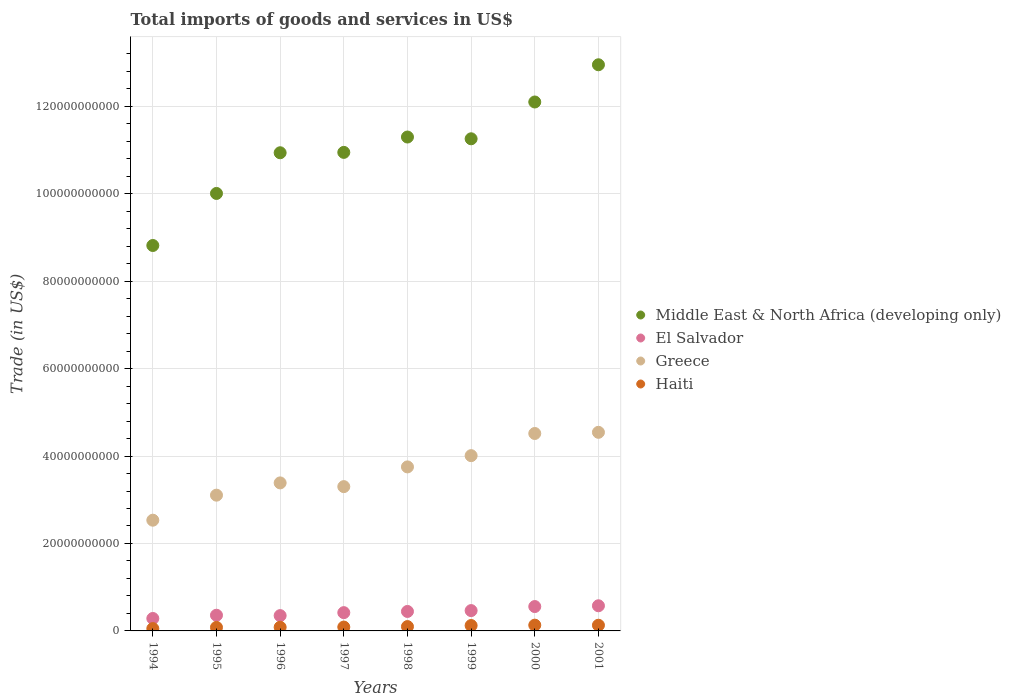How many different coloured dotlines are there?
Ensure brevity in your answer.  4. What is the total imports of goods and services in El Salvador in 1999?
Keep it short and to the point. 4.65e+09. Across all years, what is the maximum total imports of goods and services in Haiti?
Your answer should be very brief. 1.32e+09. Across all years, what is the minimum total imports of goods and services in Haiti?
Offer a terse response. 5.36e+08. In which year was the total imports of goods and services in Greece maximum?
Provide a short and direct response. 2001. In which year was the total imports of goods and services in Middle East & North Africa (developing only) minimum?
Give a very brief answer. 1994. What is the total total imports of goods and services in El Salvador in the graph?
Offer a very short reply. 3.45e+1. What is the difference between the total imports of goods and services in Greece in 1999 and that in 2001?
Your response must be concise. -5.34e+09. What is the difference between the total imports of goods and services in Greece in 1998 and the total imports of goods and services in Haiti in 1994?
Give a very brief answer. 3.70e+1. What is the average total imports of goods and services in Greece per year?
Provide a short and direct response. 3.64e+1. In the year 1995, what is the difference between the total imports of goods and services in Middle East & North Africa (developing only) and total imports of goods and services in Haiti?
Offer a very short reply. 9.92e+1. What is the ratio of the total imports of goods and services in Greece in 1994 to that in 1997?
Your answer should be compact. 0.77. Is the difference between the total imports of goods and services in Middle East & North Africa (developing only) in 1995 and 1998 greater than the difference between the total imports of goods and services in Haiti in 1995 and 1998?
Provide a short and direct response. No. What is the difference between the highest and the second highest total imports of goods and services in Haiti?
Make the answer very short. 2.14e+07. What is the difference between the highest and the lowest total imports of goods and services in Haiti?
Keep it short and to the point. 7.85e+08. In how many years, is the total imports of goods and services in Middle East & North Africa (developing only) greater than the average total imports of goods and services in Middle East & North Africa (developing only) taken over all years?
Provide a succinct answer. 4. Is it the case that in every year, the sum of the total imports of goods and services in El Salvador and total imports of goods and services in Haiti  is greater than the sum of total imports of goods and services in Greece and total imports of goods and services in Middle East & North Africa (developing only)?
Your answer should be compact. Yes. Is the total imports of goods and services in El Salvador strictly greater than the total imports of goods and services in Middle East & North Africa (developing only) over the years?
Your response must be concise. No. Are the values on the major ticks of Y-axis written in scientific E-notation?
Your answer should be compact. No. Does the graph contain any zero values?
Offer a terse response. No. How many legend labels are there?
Provide a short and direct response. 4. How are the legend labels stacked?
Give a very brief answer. Vertical. What is the title of the graph?
Ensure brevity in your answer.  Total imports of goods and services in US$. Does "West Bank and Gaza" appear as one of the legend labels in the graph?
Keep it short and to the point. No. What is the label or title of the Y-axis?
Your answer should be very brief. Trade (in US$). What is the Trade (in US$) in Middle East & North Africa (developing only) in 1994?
Keep it short and to the point. 8.81e+1. What is the Trade (in US$) in El Salvador in 1994?
Provide a succinct answer. 2.85e+09. What is the Trade (in US$) in Greece in 1994?
Provide a short and direct response. 2.53e+1. What is the Trade (in US$) in Haiti in 1994?
Your answer should be very brief. 5.36e+08. What is the Trade (in US$) of Middle East & North Africa (developing only) in 1995?
Your response must be concise. 1.00e+11. What is the Trade (in US$) in El Salvador in 1995?
Make the answer very short. 3.59e+09. What is the Trade (in US$) in Greece in 1995?
Give a very brief answer. 3.10e+1. What is the Trade (in US$) of Haiti in 1995?
Your answer should be compact. 8.08e+08. What is the Trade (in US$) of Middle East & North Africa (developing only) in 1996?
Keep it short and to the point. 1.09e+11. What is the Trade (in US$) of El Salvador in 1996?
Offer a very short reply. 3.50e+09. What is the Trade (in US$) of Greece in 1996?
Give a very brief answer. 3.39e+1. What is the Trade (in US$) of Haiti in 1996?
Offer a very short reply. 8.40e+08. What is the Trade (in US$) of Middle East & North Africa (developing only) in 1997?
Provide a short and direct response. 1.09e+11. What is the Trade (in US$) of El Salvador in 1997?
Offer a very short reply. 4.18e+09. What is the Trade (in US$) in Greece in 1997?
Offer a terse response. 3.30e+1. What is the Trade (in US$) of Haiti in 1997?
Give a very brief answer. 8.83e+08. What is the Trade (in US$) in Middle East & North Africa (developing only) in 1998?
Make the answer very short. 1.13e+11. What is the Trade (in US$) in El Salvador in 1998?
Your answer should be very brief. 4.45e+09. What is the Trade (in US$) in Greece in 1998?
Your answer should be very brief. 3.75e+1. What is the Trade (in US$) in Haiti in 1998?
Provide a short and direct response. 9.91e+08. What is the Trade (in US$) of Middle East & North Africa (developing only) in 1999?
Your response must be concise. 1.13e+11. What is the Trade (in US$) in El Salvador in 1999?
Keep it short and to the point. 4.65e+09. What is the Trade (in US$) of Greece in 1999?
Your answer should be compact. 4.01e+1. What is the Trade (in US$) in Haiti in 1999?
Give a very brief answer. 1.23e+09. What is the Trade (in US$) in Middle East & North Africa (developing only) in 2000?
Provide a succinct answer. 1.21e+11. What is the Trade (in US$) of El Salvador in 2000?
Keep it short and to the point. 5.57e+09. What is the Trade (in US$) in Greece in 2000?
Your answer should be compact. 4.52e+1. What is the Trade (in US$) in Haiti in 2000?
Give a very brief answer. 1.32e+09. What is the Trade (in US$) of Middle East & North Africa (developing only) in 2001?
Keep it short and to the point. 1.29e+11. What is the Trade (in US$) of El Salvador in 2001?
Ensure brevity in your answer.  5.75e+09. What is the Trade (in US$) in Greece in 2001?
Your answer should be compact. 4.54e+1. What is the Trade (in US$) of Haiti in 2001?
Keep it short and to the point. 1.30e+09. Across all years, what is the maximum Trade (in US$) of Middle East & North Africa (developing only)?
Ensure brevity in your answer.  1.29e+11. Across all years, what is the maximum Trade (in US$) in El Salvador?
Your answer should be very brief. 5.75e+09. Across all years, what is the maximum Trade (in US$) of Greece?
Offer a very short reply. 4.54e+1. Across all years, what is the maximum Trade (in US$) of Haiti?
Make the answer very short. 1.32e+09. Across all years, what is the minimum Trade (in US$) in Middle East & North Africa (developing only)?
Provide a short and direct response. 8.81e+1. Across all years, what is the minimum Trade (in US$) of El Salvador?
Provide a succinct answer. 2.85e+09. Across all years, what is the minimum Trade (in US$) in Greece?
Provide a succinct answer. 2.53e+1. Across all years, what is the minimum Trade (in US$) in Haiti?
Ensure brevity in your answer.  5.36e+08. What is the total Trade (in US$) in Middle East & North Africa (developing only) in the graph?
Provide a succinct answer. 8.83e+11. What is the total Trade (in US$) in El Salvador in the graph?
Keep it short and to the point. 3.45e+1. What is the total Trade (in US$) in Greece in the graph?
Offer a very short reply. 2.91e+11. What is the total Trade (in US$) of Haiti in the graph?
Your answer should be very brief. 7.91e+09. What is the difference between the Trade (in US$) in Middle East & North Africa (developing only) in 1994 and that in 1995?
Provide a short and direct response. -1.19e+1. What is the difference between the Trade (in US$) in El Salvador in 1994 and that in 1995?
Offer a very short reply. -7.40e+08. What is the difference between the Trade (in US$) in Greece in 1994 and that in 1995?
Your answer should be compact. -5.72e+09. What is the difference between the Trade (in US$) of Haiti in 1994 and that in 1995?
Your answer should be compact. -2.72e+08. What is the difference between the Trade (in US$) in Middle East & North Africa (developing only) in 1994 and that in 1996?
Make the answer very short. -2.12e+1. What is the difference between the Trade (in US$) of El Salvador in 1994 and that in 1996?
Your answer should be very brief. -6.54e+08. What is the difference between the Trade (in US$) of Greece in 1994 and that in 1996?
Your response must be concise. -8.53e+09. What is the difference between the Trade (in US$) in Haiti in 1994 and that in 1996?
Provide a short and direct response. -3.04e+08. What is the difference between the Trade (in US$) in Middle East & North Africa (developing only) in 1994 and that in 1997?
Provide a succinct answer. -2.13e+1. What is the difference between the Trade (in US$) of El Salvador in 1994 and that in 1997?
Ensure brevity in your answer.  -1.33e+09. What is the difference between the Trade (in US$) in Greece in 1994 and that in 1997?
Offer a very short reply. -7.68e+09. What is the difference between the Trade (in US$) of Haiti in 1994 and that in 1997?
Your answer should be compact. -3.47e+08. What is the difference between the Trade (in US$) of Middle East & North Africa (developing only) in 1994 and that in 1998?
Ensure brevity in your answer.  -2.48e+1. What is the difference between the Trade (in US$) in El Salvador in 1994 and that in 1998?
Provide a short and direct response. -1.61e+09. What is the difference between the Trade (in US$) of Greece in 1994 and that in 1998?
Offer a very short reply. -1.22e+1. What is the difference between the Trade (in US$) of Haiti in 1994 and that in 1998?
Offer a terse response. -4.56e+08. What is the difference between the Trade (in US$) of Middle East & North Africa (developing only) in 1994 and that in 1999?
Your answer should be very brief. -2.44e+1. What is the difference between the Trade (in US$) of El Salvador in 1994 and that in 1999?
Your response must be concise. -1.80e+09. What is the difference between the Trade (in US$) of Greece in 1994 and that in 1999?
Your response must be concise. -1.48e+1. What is the difference between the Trade (in US$) in Haiti in 1994 and that in 1999?
Provide a short and direct response. -6.98e+08. What is the difference between the Trade (in US$) of Middle East & North Africa (developing only) in 1994 and that in 2000?
Provide a short and direct response. -3.28e+1. What is the difference between the Trade (in US$) in El Salvador in 1994 and that in 2000?
Provide a succinct answer. -2.73e+09. What is the difference between the Trade (in US$) in Greece in 1994 and that in 2000?
Provide a succinct answer. -1.98e+1. What is the difference between the Trade (in US$) of Haiti in 1994 and that in 2000?
Give a very brief answer. -7.85e+08. What is the difference between the Trade (in US$) of Middle East & North Africa (developing only) in 1994 and that in 2001?
Give a very brief answer. -4.13e+1. What is the difference between the Trade (in US$) of El Salvador in 1994 and that in 2001?
Your response must be concise. -2.90e+09. What is the difference between the Trade (in US$) of Greece in 1994 and that in 2001?
Give a very brief answer. -2.01e+1. What is the difference between the Trade (in US$) in Haiti in 1994 and that in 2001?
Ensure brevity in your answer.  -7.64e+08. What is the difference between the Trade (in US$) in Middle East & North Africa (developing only) in 1995 and that in 1996?
Offer a terse response. -9.30e+09. What is the difference between the Trade (in US$) in El Salvador in 1995 and that in 1996?
Your answer should be very brief. 8.70e+07. What is the difference between the Trade (in US$) in Greece in 1995 and that in 1996?
Provide a succinct answer. -2.81e+09. What is the difference between the Trade (in US$) of Haiti in 1995 and that in 1996?
Your response must be concise. -3.23e+07. What is the difference between the Trade (in US$) in Middle East & North Africa (developing only) in 1995 and that in 1997?
Provide a short and direct response. -9.39e+09. What is the difference between the Trade (in US$) in El Salvador in 1995 and that in 1997?
Make the answer very short. -5.94e+08. What is the difference between the Trade (in US$) in Greece in 1995 and that in 1997?
Your response must be concise. -1.95e+09. What is the difference between the Trade (in US$) of Haiti in 1995 and that in 1997?
Give a very brief answer. -7.50e+07. What is the difference between the Trade (in US$) in Middle East & North Africa (developing only) in 1995 and that in 1998?
Give a very brief answer. -1.29e+1. What is the difference between the Trade (in US$) in El Salvador in 1995 and that in 1998?
Give a very brief answer. -8.66e+08. What is the difference between the Trade (in US$) in Greece in 1995 and that in 1998?
Your answer should be very brief. -6.46e+09. What is the difference between the Trade (in US$) of Haiti in 1995 and that in 1998?
Give a very brief answer. -1.83e+08. What is the difference between the Trade (in US$) of Middle East & North Africa (developing only) in 1995 and that in 1999?
Your answer should be compact. -1.25e+1. What is the difference between the Trade (in US$) in El Salvador in 1995 and that in 1999?
Make the answer very short. -1.06e+09. What is the difference between the Trade (in US$) in Greece in 1995 and that in 1999?
Provide a succinct answer. -9.04e+09. What is the difference between the Trade (in US$) in Haiti in 1995 and that in 1999?
Offer a terse response. -4.26e+08. What is the difference between the Trade (in US$) of Middle East & North Africa (developing only) in 1995 and that in 2000?
Give a very brief answer. -2.09e+1. What is the difference between the Trade (in US$) in El Salvador in 1995 and that in 2000?
Your response must be concise. -1.99e+09. What is the difference between the Trade (in US$) in Greece in 1995 and that in 2000?
Provide a succinct answer. -1.41e+1. What is the difference between the Trade (in US$) in Haiti in 1995 and that in 2000?
Keep it short and to the point. -5.13e+08. What is the difference between the Trade (in US$) of Middle East & North Africa (developing only) in 1995 and that in 2001?
Give a very brief answer. -2.94e+1. What is the difference between the Trade (in US$) of El Salvador in 1995 and that in 2001?
Your response must be concise. -2.16e+09. What is the difference between the Trade (in US$) of Greece in 1995 and that in 2001?
Ensure brevity in your answer.  -1.44e+1. What is the difference between the Trade (in US$) in Haiti in 1995 and that in 2001?
Your response must be concise. -4.92e+08. What is the difference between the Trade (in US$) in Middle East & North Africa (developing only) in 1996 and that in 1997?
Give a very brief answer. -8.62e+07. What is the difference between the Trade (in US$) of El Salvador in 1996 and that in 1997?
Offer a terse response. -6.81e+08. What is the difference between the Trade (in US$) of Greece in 1996 and that in 1997?
Make the answer very short. 8.53e+08. What is the difference between the Trade (in US$) in Haiti in 1996 and that in 1997?
Keep it short and to the point. -4.27e+07. What is the difference between the Trade (in US$) in Middle East & North Africa (developing only) in 1996 and that in 1998?
Keep it short and to the point. -3.60e+09. What is the difference between the Trade (in US$) in El Salvador in 1996 and that in 1998?
Offer a terse response. -9.53e+08. What is the difference between the Trade (in US$) of Greece in 1996 and that in 1998?
Offer a terse response. -3.66e+09. What is the difference between the Trade (in US$) of Haiti in 1996 and that in 1998?
Keep it short and to the point. -1.51e+08. What is the difference between the Trade (in US$) of Middle East & North Africa (developing only) in 1996 and that in 1999?
Offer a very short reply. -3.19e+09. What is the difference between the Trade (in US$) in El Salvador in 1996 and that in 1999?
Offer a very short reply. -1.15e+09. What is the difference between the Trade (in US$) of Greece in 1996 and that in 1999?
Your answer should be very brief. -6.23e+09. What is the difference between the Trade (in US$) in Haiti in 1996 and that in 1999?
Your response must be concise. -3.93e+08. What is the difference between the Trade (in US$) of Middle East & North Africa (developing only) in 1996 and that in 2000?
Give a very brief answer. -1.16e+1. What is the difference between the Trade (in US$) in El Salvador in 1996 and that in 2000?
Offer a terse response. -2.07e+09. What is the difference between the Trade (in US$) of Greece in 1996 and that in 2000?
Keep it short and to the point. -1.13e+1. What is the difference between the Trade (in US$) of Haiti in 1996 and that in 2000?
Your answer should be very brief. -4.81e+08. What is the difference between the Trade (in US$) in Middle East & North Africa (developing only) in 1996 and that in 2001?
Your response must be concise. -2.01e+1. What is the difference between the Trade (in US$) of El Salvador in 1996 and that in 2001?
Your response must be concise. -2.25e+09. What is the difference between the Trade (in US$) in Greece in 1996 and that in 2001?
Ensure brevity in your answer.  -1.16e+1. What is the difference between the Trade (in US$) of Haiti in 1996 and that in 2001?
Provide a succinct answer. -4.60e+08. What is the difference between the Trade (in US$) of Middle East & North Africa (developing only) in 1997 and that in 1998?
Offer a terse response. -3.51e+09. What is the difference between the Trade (in US$) of El Salvador in 1997 and that in 1998?
Your response must be concise. -2.72e+08. What is the difference between the Trade (in US$) of Greece in 1997 and that in 1998?
Ensure brevity in your answer.  -4.51e+09. What is the difference between the Trade (in US$) in Haiti in 1997 and that in 1998?
Provide a succinct answer. -1.08e+08. What is the difference between the Trade (in US$) in Middle East & North Africa (developing only) in 1997 and that in 1999?
Your answer should be very brief. -3.11e+09. What is the difference between the Trade (in US$) in El Salvador in 1997 and that in 1999?
Your answer should be very brief. -4.66e+08. What is the difference between the Trade (in US$) in Greece in 1997 and that in 1999?
Offer a terse response. -7.08e+09. What is the difference between the Trade (in US$) of Haiti in 1997 and that in 1999?
Ensure brevity in your answer.  -3.51e+08. What is the difference between the Trade (in US$) of Middle East & North Africa (developing only) in 1997 and that in 2000?
Give a very brief answer. -1.15e+1. What is the difference between the Trade (in US$) in El Salvador in 1997 and that in 2000?
Provide a short and direct response. -1.39e+09. What is the difference between the Trade (in US$) of Greece in 1997 and that in 2000?
Offer a very short reply. -1.22e+1. What is the difference between the Trade (in US$) in Haiti in 1997 and that in 2000?
Your response must be concise. -4.38e+08. What is the difference between the Trade (in US$) in Middle East & North Africa (developing only) in 1997 and that in 2001?
Keep it short and to the point. -2.00e+1. What is the difference between the Trade (in US$) in El Salvador in 1997 and that in 2001?
Ensure brevity in your answer.  -1.57e+09. What is the difference between the Trade (in US$) of Greece in 1997 and that in 2001?
Your response must be concise. -1.24e+1. What is the difference between the Trade (in US$) in Haiti in 1997 and that in 2001?
Ensure brevity in your answer.  -4.17e+08. What is the difference between the Trade (in US$) in Middle East & North Africa (developing only) in 1998 and that in 1999?
Your answer should be very brief. 4.03e+08. What is the difference between the Trade (in US$) of El Salvador in 1998 and that in 1999?
Offer a very short reply. -1.94e+08. What is the difference between the Trade (in US$) in Greece in 1998 and that in 1999?
Ensure brevity in your answer.  -2.57e+09. What is the difference between the Trade (in US$) of Haiti in 1998 and that in 1999?
Make the answer very short. -2.42e+08. What is the difference between the Trade (in US$) of Middle East & North Africa (developing only) in 1998 and that in 2000?
Provide a short and direct response. -8.01e+09. What is the difference between the Trade (in US$) in El Salvador in 1998 and that in 2000?
Your response must be concise. -1.12e+09. What is the difference between the Trade (in US$) of Greece in 1998 and that in 2000?
Your answer should be very brief. -7.64e+09. What is the difference between the Trade (in US$) in Haiti in 1998 and that in 2000?
Your answer should be compact. -3.30e+08. What is the difference between the Trade (in US$) of Middle East & North Africa (developing only) in 1998 and that in 2001?
Your answer should be compact. -1.65e+1. What is the difference between the Trade (in US$) in El Salvador in 1998 and that in 2001?
Provide a short and direct response. -1.30e+09. What is the difference between the Trade (in US$) of Greece in 1998 and that in 2001?
Give a very brief answer. -7.91e+09. What is the difference between the Trade (in US$) in Haiti in 1998 and that in 2001?
Give a very brief answer. -3.08e+08. What is the difference between the Trade (in US$) of Middle East & North Africa (developing only) in 1999 and that in 2000?
Give a very brief answer. -8.42e+09. What is the difference between the Trade (in US$) in El Salvador in 1999 and that in 2000?
Offer a terse response. -9.26e+08. What is the difference between the Trade (in US$) in Greece in 1999 and that in 2000?
Give a very brief answer. -5.07e+09. What is the difference between the Trade (in US$) in Haiti in 1999 and that in 2000?
Offer a very short reply. -8.75e+07. What is the difference between the Trade (in US$) in Middle East & North Africa (developing only) in 1999 and that in 2001?
Your answer should be very brief. -1.69e+1. What is the difference between the Trade (in US$) of El Salvador in 1999 and that in 2001?
Your response must be concise. -1.10e+09. What is the difference between the Trade (in US$) of Greece in 1999 and that in 2001?
Provide a succinct answer. -5.34e+09. What is the difference between the Trade (in US$) of Haiti in 1999 and that in 2001?
Offer a very short reply. -6.62e+07. What is the difference between the Trade (in US$) of Middle East & North Africa (developing only) in 2000 and that in 2001?
Ensure brevity in your answer.  -8.51e+09. What is the difference between the Trade (in US$) of El Salvador in 2000 and that in 2001?
Your answer should be very brief. -1.78e+08. What is the difference between the Trade (in US$) of Greece in 2000 and that in 2001?
Offer a terse response. -2.69e+08. What is the difference between the Trade (in US$) of Haiti in 2000 and that in 2001?
Provide a short and direct response. 2.14e+07. What is the difference between the Trade (in US$) in Middle East & North Africa (developing only) in 1994 and the Trade (in US$) in El Salvador in 1995?
Your answer should be compact. 8.46e+1. What is the difference between the Trade (in US$) of Middle East & North Africa (developing only) in 1994 and the Trade (in US$) of Greece in 1995?
Provide a short and direct response. 5.71e+1. What is the difference between the Trade (in US$) of Middle East & North Africa (developing only) in 1994 and the Trade (in US$) of Haiti in 1995?
Your answer should be very brief. 8.73e+1. What is the difference between the Trade (in US$) in El Salvador in 1994 and the Trade (in US$) in Greece in 1995?
Keep it short and to the point. -2.82e+1. What is the difference between the Trade (in US$) in El Salvador in 1994 and the Trade (in US$) in Haiti in 1995?
Keep it short and to the point. 2.04e+09. What is the difference between the Trade (in US$) in Greece in 1994 and the Trade (in US$) in Haiti in 1995?
Offer a very short reply. 2.45e+1. What is the difference between the Trade (in US$) of Middle East & North Africa (developing only) in 1994 and the Trade (in US$) of El Salvador in 1996?
Provide a short and direct response. 8.46e+1. What is the difference between the Trade (in US$) of Middle East & North Africa (developing only) in 1994 and the Trade (in US$) of Greece in 1996?
Your answer should be very brief. 5.43e+1. What is the difference between the Trade (in US$) of Middle East & North Africa (developing only) in 1994 and the Trade (in US$) of Haiti in 1996?
Your response must be concise. 8.73e+1. What is the difference between the Trade (in US$) of El Salvador in 1994 and the Trade (in US$) of Greece in 1996?
Offer a very short reply. -3.10e+1. What is the difference between the Trade (in US$) in El Salvador in 1994 and the Trade (in US$) in Haiti in 1996?
Offer a very short reply. 2.01e+09. What is the difference between the Trade (in US$) of Greece in 1994 and the Trade (in US$) of Haiti in 1996?
Your response must be concise. 2.45e+1. What is the difference between the Trade (in US$) in Middle East & North Africa (developing only) in 1994 and the Trade (in US$) in El Salvador in 1997?
Keep it short and to the point. 8.40e+1. What is the difference between the Trade (in US$) of Middle East & North Africa (developing only) in 1994 and the Trade (in US$) of Greece in 1997?
Your answer should be compact. 5.51e+1. What is the difference between the Trade (in US$) of Middle East & North Africa (developing only) in 1994 and the Trade (in US$) of Haiti in 1997?
Ensure brevity in your answer.  8.73e+1. What is the difference between the Trade (in US$) of El Salvador in 1994 and the Trade (in US$) of Greece in 1997?
Offer a terse response. -3.02e+1. What is the difference between the Trade (in US$) in El Salvador in 1994 and the Trade (in US$) in Haiti in 1997?
Keep it short and to the point. 1.96e+09. What is the difference between the Trade (in US$) in Greece in 1994 and the Trade (in US$) in Haiti in 1997?
Make the answer very short. 2.44e+1. What is the difference between the Trade (in US$) in Middle East & North Africa (developing only) in 1994 and the Trade (in US$) in El Salvador in 1998?
Offer a terse response. 8.37e+1. What is the difference between the Trade (in US$) in Middle East & North Africa (developing only) in 1994 and the Trade (in US$) in Greece in 1998?
Ensure brevity in your answer.  5.06e+1. What is the difference between the Trade (in US$) in Middle East & North Africa (developing only) in 1994 and the Trade (in US$) in Haiti in 1998?
Provide a succinct answer. 8.72e+1. What is the difference between the Trade (in US$) of El Salvador in 1994 and the Trade (in US$) of Greece in 1998?
Offer a terse response. -3.47e+1. What is the difference between the Trade (in US$) of El Salvador in 1994 and the Trade (in US$) of Haiti in 1998?
Your response must be concise. 1.86e+09. What is the difference between the Trade (in US$) in Greece in 1994 and the Trade (in US$) in Haiti in 1998?
Your response must be concise. 2.43e+1. What is the difference between the Trade (in US$) of Middle East & North Africa (developing only) in 1994 and the Trade (in US$) of El Salvador in 1999?
Offer a terse response. 8.35e+1. What is the difference between the Trade (in US$) in Middle East & North Africa (developing only) in 1994 and the Trade (in US$) in Greece in 1999?
Offer a terse response. 4.81e+1. What is the difference between the Trade (in US$) in Middle East & North Africa (developing only) in 1994 and the Trade (in US$) in Haiti in 1999?
Give a very brief answer. 8.69e+1. What is the difference between the Trade (in US$) of El Salvador in 1994 and the Trade (in US$) of Greece in 1999?
Keep it short and to the point. -3.72e+1. What is the difference between the Trade (in US$) in El Salvador in 1994 and the Trade (in US$) in Haiti in 1999?
Your response must be concise. 1.61e+09. What is the difference between the Trade (in US$) of Greece in 1994 and the Trade (in US$) of Haiti in 1999?
Give a very brief answer. 2.41e+1. What is the difference between the Trade (in US$) of Middle East & North Africa (developing only) in 1994 and the Trade (in US$) of El Salvador in 2000?
Make the answer very short. 8.26e+1. What is the difference between the Trade (in US$) in Middle East & North Africa (developing only) in 1994 and the Trade (in US$) in Greece in 2000?
Offer a terse response. 4.30e+1. What is the difference between the Trade (in US$) of Middle East & North Africa (developing only) in 1994 and the Trade (in US$) of Haiti in 2000?
Keep it short and to the point. 8.68e+1. What is the difference between the Trade (in US$) of El Salvador in 1994 and the Trade (in US$) of Greece in 2000?
Provide a short and direct response. -4.23e+1. What is the difference between the Trade (in US$) in El Salvador in 1994 and the Trade (in US$) in Haiti in 2000?
Your response must be concise. 1.53e+09. What is the difference between the Trade (in US$) of Greece in 1994 and the Trade (in US$) of Haiti in 2000?
Provide a succinct answer. 2.40e+1. What is the difference between the Trade (in US$) in Middle East & North Africa (developing only) in 1994 and the Trade (in US$) in El Salvador in 2001?
Ensure brevity in your answer.  8.24e+1. What is the difference between the Trade (in US$) in Middle East & North Africa (developing only) in 1994 and the Trade (in US$) in Greece in 2001?
Provide a short and direct response. 4.27e+1. What is the difference between the Trade (in US$) in Middle East & North Africa (developing only) in 1994 and the Trade (in US$) in Haiti in 2001?
Your answer should be compact. 8.68e+1. What is the difference between the Trade (in US$) in El Salvador in 1994 and the Trade (in US$) in Greece in 2001?
Keep it short and to the point. -4.26e+1. What is the difference between the Trade (in US$) in El Salvador in 1994 and the Trade (in US$) in Haiti in 2001?
Your answer should be very brief. 1.55e+09. What is the difference between the Trade (in US$) in Greece in 1994 and the Trade (in US$) in Haiti in 2001?
Your response must be concise. 2.40e+1. What is the difference between the Trade (in US$) in Middle East & North Africa (developing only) in 1995 and the Trade (in US$) in El Salvador in 1996?
Provide a short and direct response. 9.66e+1. What is the difference between the Trade (in US$) of Middle East & North Africa (developing only) in 1995 and the Trade (in US$) of Greece in 1996?
Make the answer very short. 6.62e+1. What is the difference between the Trade (in US$) in Middle East & North Africa (developing only) in 1995 and the Trade (in US$) in Haiti in 1996?
Your answer should be very brief. 9.92e+1. What is the difference between the Trade (in US$) in El Salvador in 1995 and the Trade (in US$) in Greece in 1996?
Offer a terse response. -3.03e+1. What is the difference between the Trade (in US$) in El Salvador in 1995 and the Trade (in US$) in Haiti in 1996?
Your answer should be compact. 2.75e+09. What is the difference between the Trade (in US$) of Greece in 1995 and the Trade (in US$) of Haiti in 1996?
Provide a succinct answer. 3.02e+1. What is the difference between the Trade (in US$) of Middle East & North Africa (developing only) in 1995 and the Trade (in US$) of El Salvador in 1997?
Your answer should be compact. 9.59e+1. What is the difference between the Trade (in US$) in Middle East & North Africa (developing only) in 1995 and the Trade (in US$) in Greece in 1997?
Make the answer very short. 6.71e+1. What is the difference between the Trade (in US$) in Middle East & North Africa (developing only) in 1995 and the Trade (in US$) in Haiti in 1997?
Provide a short and direct response. 9.92e+1. What is the difference between the Trade (in US$) in El Salvador in 1995 and the Trade (in US$) in Greece in 1997?
Provide a succinct answer. -2.94e+1. What is the difference between the Trade (in US$) of El Salvador in 1995 and the Trade (in US$) of Haiti in 1997?
Offer a very short reply. 2.70e+09. What is the difference between the Trade (in US$) of Greece in 1995 and the Trade (in US$) of Haiti in 1997?
Provide a succinct answer. 3.02e+1. What is the difference between the Trade (in US$) in Middle East & North Africa (developing only) in 1995 and the Trade (in US$) in El Salvador in 1998?
Offer a terse response. 9.56e+1. What is the difference between the Trade (in US$) in Middle East & North Africa (developing only) in 1995 and the Trade (in US$) in Greece in 1998?
Your answer should be compact. 6.25e+1. What is the difference between the Trade (in US$) in Middle East & North Africa (developing only) in 1995 and the Trade (in US$) in Haiti in 1998?
Provide a succinct answer. 9.91e+1. What is the difference between the Trade (in US$) of El Salvador in 1995 and the Trade (in US$) of Greece in 1998?
Keep it short and to the point. -3.39e+1. What is the difference between the Trade (in US$) in El Salvador in 1995 and the Trade (in US$) in Haiti in 1998?
Offer a terse response. 2.60e+09. What is the difference between the Trade (in US$) of Greece in 1995 and the Trade (in US$) of Haiti in 1998?
Offer a very short reply. 3.01e+1. What is the difference between the Trade (in US$) of Middle East & North Africa (developing only) in 1995 and the Trade (in US$) of El Salvador in 1999?
Make the answer very short. 9.54e+1. What is the difference between the Trade (in US$) in Middle East & North Africa (developing only) in 1995 and the Trade (in US$) in Greece in 1999?
Give a very brief answer. 6.00e+1. What is the difference between the Trade (in US$) of Middle East & North Africa (developing only) in 1995 and the Trade (in US$) of Haiti in 1999?
Your answer should be very brief. 9.88e+1. What is the difference between the Trade (in US$) in El Salvador in 1995 and the Trade (in US$) in Greece in 1999?
Give a very brief answer. -3.65e+1. What is the difference between the Trade (in US$) in El Salvador in 1995 and the Trade (in US$) in Haiti in 1999?
Provide a succinct answer. 2.35e+09. What is the difference between the Trade (in US$) of Greece in 1995 and the Trade (in US$) of Haiti in 1999?
Offer a very short reply. 2.98e+1. What is the difference between the Trade (in US$) in Middle East & North Africa (developing only) in 1995 and the Trade (in US$) in El Salvador in 2000?
Provide a succinct answer. 9.45e+1. What is the difference between the Trade (in US$) of Middle East & North Africa (developing only) in 1995 and the Trade (in US$) of Greece in 2000?
Your answer should be compact. 5.49e+1. What is the difference between the Trade (in US$) in Middle East & North Africa (developing only) in 1995 and the Trade (in US$) in Haiti in 2000?
Provide a short and direct response. 9.87e+1. What is the difference between the Trade (in US$) of El Salvador in 1995 and the Trade (in US$) of Greece in 2000?
Provide a short and direct response. -4.16e+1. What is the difference between the Trade (in US$) in El Salvador in 1995 and the Trade (in US$) in Haiti in 2000?
Make the answer very short. 2.27e+09. What is the difference between the Trade (in US$) in Greece in 1995 and the Trade (in US$) in Haiti in 2000?
Keep it short and to the point. 2.97e+1. What is the difference between the Trade (in US$) of Middle East & North Africa (developing only) in 1995 and the Trade (in US$) of El Salvador in 2001?
Your answer should be very brief. 9.43e+1. What is the difference between the Trade (in US$) of Middle East & North Africa (developing only) in 1995 and the Trade (in US$) of Greece in 2001?
Give a very brief answer. 5.46e+1. What is the difference between the Trade (in US$) in Middle East & North Africa (developing only) in 1995 and the Trade (in US$) in Haiti in 2001?
Your answer should be compact. 9.88e+1. What is the difference between the Trade (in US$) in El Salvador in 1995 and the Trade (in US$) in Greece in 2001?
Your answer should be very brief. -4.18e+1. What is the difference between the Trade (in US$) in El Salvador in 1995 and the Trade (in US$) in Haiti in 2001?
Offer a terse response. 2.29e+09. What is the difference between the Trade (in US$) in Greece in 1995 and the Trade (in US$) in Haiti in 2001?
Your answer should be compact. 2.97e+1. What is the difference between the Trade (in US$) in Middle East & North Africa (developing only) in 1996 and the Trade (in US$) in El Salvador in 1997?
Your response must be concise. 1.05e+11. What is the difference between the Trade (in US$) of Middle East & North Africa (developing only) in 1996 and the Trade (in US$) of Greece in 1997?
Your answer should be very brief. 7.64e+1. What is the difference between the Trade (in US$) in Middle East & North Africa (developing only) in 1996 and the Trade (in US$) in Haiti in 1997?
Make the answer very short. 1.08e+11. What is the difference between the Trade (in US$) of El Salvador in 1996 and the Trade (in US$) of Greece in 1997?
Make the answer very short. -2.95e+1. What is the difference between the Trade (in US$) of El Salvador in 1996 and the Trade (in US$) of Haiti in 1997?
Offer a very short reply. 2.62e+09. What is the difference between the Trade (in US$) in Greece in 1996 and the Trade (in US$) in Haiti in 1997?
Your answer should be compact. 3.30e+1. What is the difference between the Trade (in US$) in Middle East & North Africa (developing only) in 1996 and the Trade (in US$) in El Salvador in 1998?
Your answer should be very brief. 1.05e+11. What is the difference between the Trade (in US$) in Middle East & North Africa (developing only) in 1996 and the Trade (in US$) in Greece in 1998?
Your answer should be compact. 7.18e+1. What is the difference between the Trade (in US$) of Middle East & North Africa (developing only) in 1996 and the Trade (in US$) of Haiti in 1998?
Your response must be concise. 1.08e+11. What is the difference between the Trade (in US$) of El Salvador in 1996 and the Trade (in US$) of Greece in 1998?
Offer a very short reply. -3.40e+1. What is the difference between the Trade (in US$) of El Salvador in 1996 and the Trade (in US$) of Haiti in 1998?
Offer a terse response. 2.51e+09. What is the difference between the Trade (in US$) of Greece in 1996 and the Trade (in US$) of Haiti in 1998?
Offer a terse response. 3.29e+1. What is the difference between the Trade (in US$) of Middle East & North Africa (developing only) in 1996 and the Trade (in US$) of El Salvador in 1999?
Give a very brief answer. 1.05e+11. What is the difference between the Trade (in US$) in Middle East & North Africa (developing only) in 1996 and the Trade (in US$) in Greece in 1999?
Your answer should be compact. 6.93e+1. What is the difference between the Trade (in US$) of Middle East & North Africa (developing only) in 1996 and the Trade (in US$) of Haiti in 1999?
Provide a succinct answer. 1.08e+11. What is the difference between the Trade (in US$) of El Salvador in 1996 and the Trade (in US$) of Greece in 1999?
Keep it short and to the point. -3.66e+1. What is the difference between the Trade (in US$) in El Salvador in 1996 and the Trade (in US$) in Haiti in 1999?
Offer a terse response. 2.27e+09. What is the difference between the Trade (in US$) in Greece in 1996 and the Trade (in US$) in Haiti in 1999?
Give a very brief answer. 3.26e+1. What is the difference between the Trade (in US$) of Middle East & North Africa (developing only) in 1996 and the Trade (in US$) of El Salvador in 2000?
Offer a very short reply. 1.04e+11. What is the difference between the Trade (in US$) of Middle East & North Africa (developing only) in 1996 and the Trade (in US$) of Greece in 2000?
Your answer should be very brief. 6.42e+1. What is the difference between the Trade (in US$) of Middle East & North Africa (developing only) in 1996 and the Trade (in US$) of Haiti in 2000?
Keep it short and to the point. 1.08e+11. What is the difference between the Trade (in US$) in El Salvador in 1996 and the Trade (in US$) in Greece in 2000?
Provide a short and direct response. -4.17e+1. What is the difference between the Trade (in US$) of El Salvador in 1996 and the Trade (in US$) of Haiti in 2000?
Offer a terse response. 2.18e+09. What is the difference between the Trade (in US$) of Greece in 1996 and the Trade (in US$) of Haiti in 2000?
Your answer should be compact. 3.25e+1. What is the difference between the Trade (in US$) of Middle East & North Africa (developing only) in 1996 and the Trade (in US$) of El Salvador in 2001?
Make the answer very short. 1.04e+11. What is the difference between the Trade (in US$) of Middle East & North Africa (developing only) in 1996 and the Trade (in US$) of Greece in 2001?
Keep it short and to the point. 6.39e+1. What is the difference between the Trade (in US$) of Middle East & North Africa (developing only) in 1996 and the Trade (in US$) of Haiti in 2001?
Offer a very short reply. 1.08e+11. What is the difference between the Trade (in US$) of El Salvador in 1996 and the Trade (in US$) of Greece in 2001?
Ensure brevity in your answer.  -4.19e+1. What is the difference between the Trade (in US$) in El Salvador in 1996 and the Trade (in US$) in Haiti in 2001?
Provide a short and direct response. 2.20e+09. What is the difference between the Trade (in US$) of Greece in 1996 and the Trade (in US$) of Haiti in 2001?
Offer a very short reply. 3.26e+1. What is the difference between the Trade (in US$) in Middle East & North Africa (developing only) in 1997 and the Trade (in US$) in El Salvador in 1998?
Ensure brevity in your answer.  1.05e+11. What is the difference between the Trade (in US$) of Middle East & North Africa (developing only) in 1997 and the Trade (in US$) of Greece in 1998?
Provide a short and direct response. 7.19e+1. What is the difference between the Trade (in US$) of Middle East & North Africa (developing only) in 1997 and the Trade (in US$) of Haiti in 1998?
Keep it short and to the point. 1.08e+11. What is the difference between the Trade (in US$) in El Salvador in 1997 and the Trade (in US$) in Greece in 1998?
Offer a very short reply. -3.33e+1. What is the difference between the Trade (in US$) of El Salvador in 1997 and the Trade (in US$) of Haiti in 1998?
Offer a terse response. 3.19e+09. What is the difference between the Trade (in US$) of Greece in 1997 and the Trade (in US$) of Haiti in 1998?
Your response must be concise. 3.20e+1. What is the difference between the Trade (in US$) of Middle East & North Africa (developing only) in 1997 and the Trade (in US$) of El Salvador in 1999?
Give a very brief answer. 1.05e+11. What is the difference between the Trade (in US$) of Middle East & North Africa (developing only) in 1997 and the Trade (in US$) of Greece in 1999?
Give a very brief answer. 6.94e+1. What is the difference between the Trade (in US$) in Middle East & North Africa (developing only) in 1997 and the Trade (in US$) in Haiti in 1999?
Your answer should be very brief. 1.08e+11. What is the difference between the Trade (in US$) in El Salvador in 1997 and the Trade (in US$) in Greece in 1999?
Offer a very short reply. -3.59e+1. What is the difference between the Trade (in US$) of El Salvador in 1997 and the Trade (in US$) of Haiti in 1999?
Offer a terse response. 2.95e+09. What is the difference between the Trade (in US$) of Greece in 1997 and the Trade (in US$) of Haiti in 1999?
Offer a very short reply. 3.18e+1. What is the difference between the Trade (in US$) of Middle East & North Africa (developing only) in 1997 and the Trade (in US$) of El Salvador in 2000?
Provide a succinct answer. 1.04e+11. What is the difference between the Trade (in US$) of Middle East & North Africa (developing only) in 1997 and the Trade (in US$) of Greece in 2000?
Keep it short and to the point. 6.43e+1. What is the difference between the Trade (in US$) in Middle East & North Africa (developing only) in 1997 and the Trade (in US$) in Haiti in 2000?
Your answer should be very brief. 1.08e+11. What is the difference between the Trade (in US$) in El Salvador in 1997 and the Trade (in US$) in Greece in 2000?
Offer a very short reply. -4.10e+1. What is the difference between the Trade (in US$) in El Salvador in 1997 and the Trade (in US$) in Haiti in 2000?
Your answer should be very brief. 2.86e+09. What is the difference between the Trade (in US$) in Greece in 1997 and the Trade (in US$) in Haiti in 2000?
Offer a very short reply. 3.17e+1. What is the difference between the Trade (in US$) in Middle East & North Africa (developing only) in 1997 and the Trade (in US$) in El Salvador in 2001?
Provide a short and direct response. 1.04e+11. What is the difference between the Trade (in US$) of Middle East & North Africa (developing only) in 1997 and the Trade (in US$) of Greece in 2001?
Make the answer very short. 6.40e+1. What is the difference between the Trade (in US$) in Middle East & North Africa (developing only) in 1997 and the Trade (in US$) in Haiti in 2001?
Keep it short and to the point. 1.08e+11. What is the difference between the Trade (in US$) in El Salvador in 1997 and the Trade (in US$) in Greece in 2001?
Provide a succinct answer. -4.12e+1. What is the difference between the Trade (in US$) of El Salvador in 1997 and the Trade (in US$) of Haiti in 2001?
Provide a short and direct response. 2.88e+09. What is the difference between the Trade (in US$) in Greece in 1997 and the Trade (in US$) in Haiti in 2001?
Ensure brevity in your answer.  3.17e+1. What is the difference between the Trade (in US$) in Middle East & North Africa (developing only) in 1998 and the Trade (in US$) in El Salvador in 1999?
Give a very brief answer. 1.08e+11. What is the difference between the Trade (in US$) in Middle East & North Africa (developing only) in 1998 and the Trade (in US$) in Greece in 1999?
Keep it short and to the point. 7.29e+1. What is the difference between the Trade (in US$) in Middle East & North Africa (developing only) in 1998 and the Trade (in US$) in Haiti in 1999?
Provide a short and direct response. 1.12e+11. What is the difference between the Trade (in US$) in El Salvador in 1998 and the Trade (in US$) in Greece in 1999?
Make the answer very short. -3.56e+1. What is the difference between the Trade (in US$) in El Salvador in 1998 and the Trade (in US$) in Haiti in 1999?
Ensure brevity in your answer.  3.22e+09. What is the difference between the Trade (in US$) in Greece in 1998 and the Trade (in US$) in Haiti in 1999?
Your answer should be compact. 3.63e+1. What is the difference between the Trade (in US$) in Middle East & North Africa (developing only) in 1998 and the Trade (in US$) in El Salvador in 2000?
Offer a very short reply. 1.07e+11. What is the difference between the Trade (in US$) in Middle East & North Africa (developing only) in 1998 and the Trade (in US$) in Greece in 2000?
Offer a terse response. 6.78e+1. What is the difference between the Trade (in US$) of Middle East & North Africa (developing only) in 1998 and the Trade (in US$) of Haiti in 2000?
Provide a succinct answer. 1.12e+11. What is the difference between the Trade (in US$) in El Salvador in 1998 and the Trade (in US$) in Greece in 2000?
Offer a very short reply. -4.07e+1. What is the difference between the Trade (in US$) in El Salvador in 1998 and the Trade (in US$) in Haiti in 2000?
Provide a succinct answer. 3.13e+09. What is the difference between the Trade (in US$) of Greece in 1998 and the Trade (in US$) of Haiti in 2000?
Ensure brevity in your answer.  3.62e+1. What is the difference between the Trade (in US$) in Middle East & North Africa (developing only) in 1998 and the Trade (in US$) in El Salvador in 2001?
Your response must be concise. 1.07e+11. What is the difference between the Trade (in US$) of Middle East & North Africa (developing only) in 1998 and the Trade (in US$) of Greece in 2001?
Your answer should be very brief. 6.75e+1. What is the difference between the Trade (in US$) of Middle East & North Africa (developing only) in 1998 and the Trade (in US$) of Haiti in 2001?
Give a very brief answer. 1.12e+11. What is the difference between the Trade (in US$) of El Salvador in 1998 and the Trade (in US$) of Greece in 2001?
Your answer should be very brief. -4.10e+1. What is the difference between the Trade (in US$) in El Salvador in 1998 and the Trade (in US$) in Haiti in 2001?
Make the answer very short. 3.15e+09. What is the difference between the Trade (in US$) of Greece in 1998 and the Trade (in US$) of Haiti in 2001?
Provide a short and direct response. 3.62e+1. What is the difference between the Trade (in US$) in Middle East & North Africa (developing only) in 1999 and the Trade (in US$) in El Salvador in 2000?
Give a very brief answer. 1.07e+11. What is the difference between the Trade (in US$) in Middle East & North Africa (developing only) in 1999 and the Trade (in US$) in Greece in 2000?
Make the answer very short. 6.74e+1. What is the difference between the Trade (in US$) of Middle East & North Africa (developing only) in 1999 and the Trade (in US$) of Haiti in 2000?
Give a very brief answer. 1.11e+11. What is the difference between the Trade (in US$) in El Salvador in 1999 and the Trade (in US$) in Greece in 2000?
Keep it short and to the point. -4.05e+1. What is the difference between the Trade (in US$) in El Salvador in 1999 and the Trade (in US$) in Haiti in 2000?
Ensure brevity in your answer.  3.33e+09. What is the difference between the Trade (in US$) of Greece in 1999 and the Trade (in US$) of Haiti in 2000?
Offer a terse response. 3.88e+1. What is the difference between the Trade (in US$) of Middle East & North Africa (developing only) in 1999 and the Trade (in US$) of El Salvador in 2001?
Keep it short and to the point. 1.07e+11. What is the difference between the Trade (in US$) of Middle East & North Africa (developing only) in 1999 and the Trade (in US$) of Greece in 2001?
Your answer should be very brief. 6.71e+1. What is the difference between the Trade (in US$) of Middle East & North Africa (developing only) in 1999 and the Trade (in US$) of Haiti in 2001?
Make the answer very short. 1.11e+11. What is the difference between the Trade (in US$) of El Salvador in 1999 and the Trade (in US$) of Greece in 2001?
Give a very brief answer. -4.08e+1. What is the difference between the Trade (in US$) in El Salvador in 1999 and the Trade (in US$) in Haiti in 2001?
Ensure brevity in your answer.  3.35e+09. What is the difference between the Trade (in US$) in Greece in 1999 and the Trade (in US$) in Haiti in 2001?
Offer a terse response. 3.88e+1. What is the difference between the Trade (in US$) in Middle East & North Africa (developing only) in 2000 and the Trade (in US$) in El Salvador in 2001?
Provide a succinct answer. 1.15e+11. What is the difference between the Trade (in US$) in Middle East & North Africa (developing only) in 2000 and the Trade (in US$) in Greece in 2001?
Your response must be concise. 7.55e+1. What is the difference between the Trade (in US$) of Middle East & North Africa (developing only) in 2000 and the Trade (in US$) of Haiti in 2001?
Your response must be concise. 1.20e+11. What is the difference between the Trade (in US$) in El Salvador in 2000 and the Trade (in US$) in Greece in 2001?
Your answer should be compact. -3.98e+1. What is the difference between the Trade (in US$) in El Salvador in 2000 and the Trade (in US$) in Haiti in 2001?
Your response must be concise. 4.27e+09. What is the difference between the Trade (in US$) in Greece in 2000 and the Trade (in US$) in Haiti in 2001?
Give a very brief answer. 4.39e+1. What is the average Trade (in US$) in Middle East & North Africa (developing only) per year?
Provide a succinct answer. 1.10e+11. What is the average Trade (in US$) of El Salvador per year?
Offer a terse response. 4.32e+09. What is the average Trade (in US$) of Greece per year?
Your answer should be very brief. 3.64e+1. What is the average Trade (in US$) of Haiti per year?
Offer a very short reply. 9.89e+08. In the year 1994, what is the difference between the Trade (in US$) in Middle East & North Africa (developing only) and Trade (in US$) in El Salvador?
Provide a short and direct response. 8.53e+1. In the year 1994, what is the difference between the Trade (in US$) of Middle East & North Africa (developing only) and Trade (in US$) of Greece?
Offer a terse response. 6.28e+1. In the year 1994, what is the difference between the Trade (in US$) in Middle East & North Africa (developing only) and Trade (in US$) in Haiti?
Keep it short and to the point. 8.76e+1. In the year 1994, what is the difference between the Trade (in US$) in El Salvador and Trade (in US$) in Greece?
Make the answer very short. -2.25e+1. In the year 1994, what is the difference between the Trade (in US$) in El Salvador and Trade (in US$) in Haiti?
Offer a terse response. 2.31e+09. In the year 1994, what is the difference between the Trade (in US$) of Greece and Trade (in US$) of Haiti?
Offer a very short reply. 2.48e+1. In the year 1995, what is the difference between the Trade (in US$) in Middle East & North Africa (developing only) and Trade (in US$) in El Salvador?
Ensure brevity in your answer.  9.65e+1. In the year 1995, what is the difference between the Trade (in US$) in Middle East & North Africa (developing only) and Trade (in US$) in Greece?
Provide a short and direct response. 6.90e+1. In the year 1995, what is the difference between the Trade (in US$) in Middle East & North Africa (developing only) and Trade (in US$) in Haiti?
Offer a terse response. 9.92e+1. In the year 1995, what is the difference between the Trade (in US$) of El Salvador and Trade (in US$) of Greece?
Offer a terse response. -2.75e+1. In the year 1995, what is the difference between the Trade (in US$) in El Salvador and Trade (in US$) in Haiti?
Your response must be concise. 2.78e+09. In the year 1995, what is the difference between the Trade (in US$) of Greece and Trade (in US$) of Haiti?
Make the answer very short. 3.02e+1. In the year 1996, what is the difference between the Trade (in US$) in Middle East & North Africa (developing only) and Trade (in US$) in El Salvador?
Offer a very short reply. 1.06e+11. In the year 1996, what is the difference between the Trade (in US$) of Middle East & North Africa (developing only) and Trade (in US$) of Greece?
Give a very brief answer. 7.55e+1. In the year 1996, what is the difference between the Trade (in US$) of Middle East & North Africa (developing only) and Trade (in US$) of Haiti?
Keep it short and to the point. 1.09e+11. In the year 1996, what is the difference between the Trade (in US$) of El Salvador and Trade (in US$) of Greece?
Your response must be concise. -3.04e+1. In the year 1996, what is the difference between the Trade (in US$) in El Salvador and Trade (in US$) in Haiti?
Give a very brief answer. 2.66e+09. In the year 1996, what is the difference between the Trade (in US$) of Greece and Trade (in US$) of Haiti?
Keep it short and to the point. 3.30e+1. In the year 1997, what is the difference between the Trade (in US$) in Middle East & North Africa (developing only) and Trade (in US$) in El Salvador?
Give a very brief answer. 1.05e+11. In the year 1997, what is the difference between the Trade (in US$) in Middle East & North Africa (developing only) and Trade (in US$) in Greece?
Offer a terse response. 7.64e+1. In the year 1997, what is the difference between the Trade (in US$) in Middle East & North Africa (developing only) and Trade (in US$) in Haiti?
Offer a very short reply. 1.09e+11. In the year 1997, what is the difference between the Trade (in US$) in El Salvador and Trade (in US$) in Greece?
Give a very brief answer. -2.88e+1. In the year 1997, what is the difference between the Trade (in US$) in El Salvador and Trade (in US$) in Haiti?
Give a very brief answer. 3.30e+09. In the year 1997, what is the difference between the Trade (in US$) of Greece and Trade (in US$) of Haiti?
Provide a succinct answer. 3.21e+1. In the year 1998, what is the difference between the Trade (in US$) of Middle East & North Africa (developing only) and Trade (in US$) of El Salvador?
Provide a short and direct response. 1.09e+11. In the year 1998, what is the difference between the Trade (in US$) of Middle East & North Africa (developing only) and Trade (in US$) of Greece?
Make the answer very short. 7.54e+1. In the year 1998, what is the difference between the Trade (in US$) in Middle East & North Africa (developing only) and Trade (in US$) in Haiti?
Provide a short and direct response. 1.12e+11. In the year 1998, what is the difference between the Trade (in US$) in El Salvador and Trade (in US$) in Greece?
Your response must be concise. -3.31e+1. In the year 1998, what is the difference between the Trade (in US$) in El Salvador and Trade (in US$) in Haiti?
Provide a succinct answer. 3.46e+09. In the year 1998, what is the difference between the Trade (in US$) of Greece and Trade (in US$) of Haiti?
Ensure brevity in your answer.  3.65e+1. In the year 1999, what is the difference between the Trade (in US$) in Middle East & North Africa (developing only) and Trade (in US$) in El Salvador?
Give a very brief answer. 1.08e+11. In the year 1999, what is the difference between the Trade (in US$) of Middle East & North Africa (developing only) and Trade (in US$) of Greece?
Your answer should be compact. 7.25e+1. In the year 1999, what is the difference between the Trade (in US$) of Middle East & North Africa (developing only) and Trade (in US$) of Haiti?
Ensure brevity in your answer.  1.11e+11. In the year 1999, what is the difference between the Trade (in US$) in El Salvador and Trade (in US$) in Greece?
Ensure brevity in your answer.  -3.54e+1. In the year 1999, what is the difference between the Trade (in US$) of El Salvador and Trade (in US$) of Haiti?
Ensure brevity in your answer.  3.41e+09. In the year 1999, what is the difference between the Trade (in US$) in Greece and Trade (in US$) in Haiti?
Your answer should be very brief. 3.89e+1. In the year 2000, what is the difference between the Trade (in US$) in Middle East & North Africa (developing only) and Trade (in US$) in El Salvador?
Keep it short and to the point. 1.15e+11. In the year 2000, what is the difference between the Trade (in US$) in Middle East & North Africa (developing only) and Trade (in US$) in Greece?
Provide a succinct answer. 7.58e+1. In the year 2000, what is the difference between the Trade (in US$) in Middle East & North Africa (developing only) and Trade (in US$) in Haiti?
Your response must be concise. 1.20e+11. In the year 2000, what is the difference between the Trade (in US$) of El Salvador and Trade (in US$) of Greece?
Your response must be concise. -3.96e+1. In the year 2000, what is the difference between the Trade (in US$) of El Salvador and Trade (in US$) of Haiti?
Your answer should be compact. 4.25e+09. In the year 2000, what is the difference between the Trade (in US$) in Greece and Trade (in US$) in Haiti?
Your answer should be compact. 4.38e+1. In the year 2001, what is the difference between the Trade (in US$) in Middle East & North Africa (developing only) and Trade (in US$) in El Salvador?
Give a very brief answer. 1.24e+11. In the year 2001, what is the difference between the Trade (in US$) in Middle East & North Africa (developing only) and Trade (in US$) in Greece?
Ensure brevity in your answer.  8.41e+1. In the year 2001, what is the difference between the Trade (in US$) of Middle East & North Africa (developing only) and Trade (in US$) of Haiti?
Your answer should be compact. 1.28e+11. In the year 2001, what is the difference between the Trade (in US$) of El Salvador and Trade (in US$) of Greece?
Offer a terse response. -3.97e+1. In the year 2001, what is the difference between the Trade (in US$) of El Salvador and Trade (in US$) of Haiti?
Provide a succinct answer. 4.45e+09. In the year 2001, what is the difference between the Trade (in US$) of Greece and Trade (in US$) of Haiti?
Your answer should be compact. 4.41e+1. What is the ratio of the Trade (in US$) in Middle East & North Africa (developing only) in 1994 to that in 1995?
Offer a terse response. 0.88. What is the ratio of the Trade (in US$) in El Salvador in 1994 to that in 1995?
Provide a short and direct response. 0.79. What is the ratio of the Trade (in US$) of Greece in 1994 to that in 1995?
Your response must be concise. 0.82. What is the ratio of the Trade (in US$) of Haiti in 1994 to that in 1995?
Provide a succinct answer. 0.66. What is the ratio of the Trade (in US$) in Middle East & North Africa (developing only) in 1994 to that in 1996?
Keep it short and to the point. 0.81. What is the ratio of the Trade (in US$) of El Salvador in 1994 to that in 1996?
Ensure brevity in your answer.  0.81. What is the ratio of the Trade (in US$) of Greece in 1994 to that in 1996?
Offer a very short reply. 0.75. What is the ratio of the Trade (in US$) of Haiti in 1994 to that in 1996?
Make the answer very short. 0.64. What is the ratio of the Trade (in US$) in Middle East & North Africa (developing only) in 1994 to that in 1997?
Provide a short and direct response. 0.81. What is the ratio of the Trade (in US$) of El Salvador in 1994 to that in 1997?
Offer a very short reply. 0.68. What is the ratio of the Trade (in US$) in Greece in 1994 to that in 1997?
Offer a very short reply. 0.77. What is the ratio of the Trade (in US$) of Haiti in 1994 to that in 1997?
Give a very brief answer. 0.61. What is the ratio of the Trade (in US$) in Middle East & North Africa (developing only) in 1994 to that in 1998?
Ensure brevity in your answer.  0.78. What is the ratio of the Trade (in US$) of El Salvador in 1994 to that in 1998?
Give a very brief answer. 0.64. What is the ratio of the Trade (in US$) of Greece in 1994 to that in 1998?
Provide a succinct answer. 0.68. What is the ratio of the Trade (in US$) of Haiti in 1994 to that in 1998?
Give a very brief answer. 0.54. What is the ratio of the Trade (in US$) in Middle East & North Africa (developing only) in 1994 to that in 1999?
Your response must be concise. 0.78. What is the ratio of the Trade (in US$) in El Salvador in 1994 to that in 1999?
Offer a terse response. 0.61. What is the ratio of the Trade (in US$) of Greece in 1994 to that in 1999?
Your answer should be compact. 0.63. What is the ratio of the Trade (in US$) in Haiti in 1994 to that in 1999?
Offer a very short reply. 0.43. What is the ratio of the Trade (in US$) of Middle East & North Africa (developing only) in 1994 to that in 2000?
Make the answer very short. 0.73. What is the ratio of the Trade (in US$) of El Salvador in 1994 to that in 2000?
Give a very brief answer. 0.51. What is the ratio of the Trade (in US$) of Greece in 1994 to that in 2000?
Offer a terse response. 0.56. What is the ratio of the Trade (in US$) of Haiti in 1994 to that in 2000?
Give a very brief answer. 0.41. What is the ratio of the Trade (in US$) in Middle East & North Africa (developing only) in 1994 to that in 2001?
Your response must be concise. 0.68. What is the ratio of the Trade (in US$) in El Salvador in 1994 to that in 2001?
Provide a succinct answer. 0.49. What is the ratio of the Trade (in US$) of Greece in 1994 to that in 2001?
Provide a succinct answer. 0.56. What is the ratio of the Trade (in US$) of Haiti in 1994 to that in 2001?
Your answer should be very brief. 0.41. What is the ratio of the Trade (in US$) in Middle East & North Africa (developing only) in 1995 to that in 1996?
Your answer should be very brief. 0.91. What is the ratio of the Trade (in US$) of El Salvador in 1995 to that in 1996?
Make the answer very short. 1.02. What is the ratio of the Trade (in US$) in Greece in 1995 to that in 1996?
Provide a succinct answer. 0.92. What is the ratio of the Trade (in US$) of Haiti in 1995 to that in 1996?
Offer a very short reply. 0.96. What is the ratio of the Trade (in US$) in Middle East & North Africa (developing only) in 1995 to that in 1997?
Provide a short and direct response. 0.91. What is the ratio of the Trade (in US$) in El Salvador in 1995 to that in 1997?
Offer a terse response. 0.86. What is the ratio of the Trade (in US$) in Greece in 1995 to that in 1997?
Offer a terse response. 0.94. What is the ratio of the Trade (in US$) in Haiti in 1995 to that in 1997?
Your answer should be compact. 0.92. What is the ratio of the Trade (in US$) in Middle East & North Africa (developing only) in 1995 to that in 1998?
Your answer should be very brief. 0.89. What is the ratio of the Trade (in US$) in El Salvador in 1995 to that in 1998?
Make the answer very short. 0.81. What is the ratio of the Trade (in US$) in Greece in 1995 to that in 1998?
Offer a terse response. 0.83. What is the ratio of the Trade (in US$) in Haiti in 1995 to that in 1998?
Your answer should be compact. 0.81. What is the ratio of the Trade (in US$) of El Salvador in 1995 to that in 1999?
Your answer should be very brief. 0.77. What is the ratio of the Trade (in US$) in Greece in 1995 to that in 1999?
Provide a succinct answer. 0.77. What is the ratio of the Trade (in US$) in Haiti in 1995 to that in 1999?
Keep it short and to the point. 0.65. What is the ratio of the Trade (in US$) of Middle East & North Africa (developing only) in 1995 to that in 2000?
Your answer should be compact. 0.83. What is the ratio of the Trade (in US$) of El Salvador in 1995 to that in 2000?
Your response must be concise. 0.64. What is the ratio of the Trade (in US$) in Greece in 1995 to that in 2000?
Give a very brief answer. 0.69. What is the ratio of the Trade (in US$) in Haiti in 1995 to that in 2000?
Make the answer very short. 0.61. What is the ratio of the Trade (in US$) of Middle East & North Africa (developing only) in 1995 to that in 2001?
Keep it short and to the point. 0.77. What is the ratio of the Trade (in US$) in El Salvador in 1995 to that in 2001?
Provide a succinct answer. 0.62. What is the ratio of the Trade (in US$) in Greece in 1995 to that in 2001?
Your response must be concise. 0.68. What is the ratio of the Trade (in US$) in Haiti in 1995 to that in 2001?
Your answer should be very brief. 0.62. What is the ratio of the Trade (in US$) in Middle East & North Africa (developing only) in 1996 to that in 1997?
Ensure brevity in your answer.  1. What is the ratio of the Trade (in US$) of El Salvador in 1996 to that in 1997?
Make the answer very short. 0.84. What is the ratio of the Trade (in US$) in Greece in 1996 to that in 1997?
Your response must be concise. 1.03. What is the ratio of the Trade (in US$) in Haiti in 1996 to that in 1997?
Make the answer very short. 0.95. What is the ratio of the Trade (in US$) in Middle East & North Africa (developing only) in 1996 to that in 1998?
Your answer should be compact. 0.97. What is the ratio of the Trade (in US$) in El Salvador in 1996 to that in 1998?
Your response must be concise. 0.79. What is the ratio of the Trade (in US$) in Greece in 1996 to that in 1998?
Your response must be concise. 0.9. What is the ratio of the Trade (in US$) of Haiti in 1996 to that in 1998?
Offer a very short reply. 0.85. What is the ratio of the Trade (in US$) of Middle East & North Africa (developing only) in 1996 to that in 1999?
Offer a terse response. 0.97. What is the ratio of the Trade (in US$) in El Salvador in 1996 to that in 1999?
Offer a terse response. 0.75. What is the ratio of the Trade (in US$) in Greece in 1996 to that in 1999?
Make the answer very short. 0.84. What is the ratio of the Trade (in US$) of Haiti in 1996 to that in 1999?
Offer a terse response. 0.68. What is the ratio of the Trade (in US$) in Middle East & North Africa (developing only) in 1996 to that in 2000?
Give a very brief answer. 0.9. What is the ratio of the Trade (in US$) of El Salvador in 1996 to that in 2000?
Provide a short and direct response. 0.63. What is the ratio of the Trade (in US$) in Greece in 1996 to that in 2000?
Keep it short and to the point. 0.75. What is the ratio of the Trade (in US$) in Haiti in 1996 to that in 2000?
Offer a terse response. 0.64. What is the ratio of the Trade (in US$) of Middle East & North Africa (developing only) in 1996 to that in 2001?
Keep it short and to the point. 0.84. What is the ratio of the Trade (in US$) in El Salvador in 1996 to that in 2001?
Give a very brief answer. 0.61. What is the ratio of the Trade (in US$) of Greece in 1996 to that in 2001?
Offer a very short reply. 0.75. What is the ratio of the Trade (in US$) of Haiti in 1996 to that in 2001?
Keep it short and to the point. 0.65. What is the ratio of the Trade (in US$) of Middle East & North Africa (developing only) in 1997 to that in 1998?
Keep it short and to the point. 0.97. What is the ratio of the Trade (in US$) of El Salvador in 1997 to that in 1998?
Keep it short and to the point. 0.94. What is the ratio of the Trade (in US$) in Greece in 1997 to that in 1998?
Your answer should be very brief. 0.88. What is the ratio of the Trade (in US$) of Haiti in 1997 to that in 1998?
Provide a succinct answer. 0.89. What is the ratio of the Trade (in US$) of Middle East & North Africa (developing only) in 1997 to that in 1999?
Offer a very short reply. 0.97. What is the ratio of the Trade (in US$) in El Salvador in 1997 to that in 1999?
Provide a succinct answer. 0.9. What is the ratio of the Trade (in US$) in Greece in 1997 to that in 1999?
Make the answer very short. 0.82. What is the ratio of the Trade (in US$) in Haiti in 1997 to that in 1999?
Your response must be concise. 0.72. What is the ratio of the Trade (in US$) in Middle East & North Africa (developing only) in 1997 to that in 2000?
Your answer should be compact. 0.9. What is the ratio of the Trade (in US$) of El Salvador in 1997 to that in 2000?
Offer a very short reply. 0.75. What is the ratio of the Trade (in US$) of Greece in 1997 to that in 2000?
Ensure brevity in your answer.  0.73. What is the ratio of the Trade (in US$) in Haiti in 1997 to that in 2000?
Your response must be concise. 0.67. What is the ratio of the Trade (in US$) in Middle East & North Africa (developing only) in 1997 to that in 2001?
Make the answer very short. 0.85. What is the ratio of the Trade (in US$) of El Salvador in 1997 to that in 2001?
Your answer should be compact. 0.73. What is the ratio of the Trade (in US$) of Greece in 1997 to that in 2001?
Your response must be concise. 0.73. What is the ratio of the Trade (in US$) of Haiti in 1997 to that in 2001?
Offer a very short reply. 0.68. What is the ratio of the Trade (in US$) of Middle East & North Africa (developing only) in 1998 to that in 1999?
Ensure brevity in your answer.  1. What is the ratio of the Trade (in US$) in Greece in 1998 to that in 1999?
Your answer should be very brief. 0.94. What is the ratio of the Trade (in US$) in Haiti in 1998 to that in 1999?
Make the answer very short. 0.8. What is the ratio of the Trade (in US$) of Middle East & North Africa (developing only) in 1998 to that in 2000?
Provide a short and direct response. 0.93. What is the ratio of the Trade (in US$) of El Salvador in 1998 to that in 2000?
Offer a very short reply. 0.8. What is the ratio of the Trade (in US$) of Greece in 1998 to that in 2000?
Offer a very short reply. 0.83. What is the ratio of the Trade (in US$) in Haiti in 1998 to that in 2000?
Ensure brevity in your answer.  0.75. What is the ratio of the Trade (in US$) in Middle East & North Africa (developing only) in 1998 to that in 2001?
Give a very brief answer. 0.87. What is the ratio of the Trade (in US$) in El Salvador in 1998 to that in 2001?
Make the answer very short. 0.77. What is the ratio of the Trade (in US$) of Greece in 1998 to that in 2001?
Your response must be concise. 0.83. What is the ratio of the Trade (in US$) in Haiti in 1998 to that in 2001?
Provide a succinct answer. 0.76. What is the ratio of the Trade (in US$) of Middle East & North Africa (developing only) in 1999 to that in 2000?
Give a very brief answer. 0.93. What is the ratio of the Trade (in US$) of El Salvador in 1999 to that in 2000?
Ensure brevity in your answer.  0.83. What is the ratio of the Trade (in US$) of Greece in 1999 to that in 2000?
Keep it short and to the point. 0.89. What is the ratio of the Trade (in US$) of Haiti in 1999 to that in 2000?
Your answer should be compact. 0.93. What is the ratio of the Trade (in US$) in Middle East & North Africa (developing only) in 1999 to that in 2001?
Your response must be concise. 0.87. What is the ratio of the Trade (in US$) in El Salvador in 1999 to that in 2001?
Provide a succinct answer. 0.81. What is the ratio of the Trade (in US$) of Greece in 1999 to that in 2001?
Provide a short and direct response. 0.88. What is the ratio of the Trade (in US$) of Haiti in 1999 to that in 2001?
Your response must be concise. 0.95. What is the ratio of the Trade (in US$) of Middle East & North Africa (developing only) in 2000 to that in 2001?
Provide a short and direct response. 0.93. What is the ratio of the Trade (in US$) in El Salvador in 2000 to that in 2001?
Provide a succinct answer. 0.97. What is the ratio of the Trade (in US$) of Greece in 2000 to that in 2001?
Your response must be concise. 0.99. What is the ratio of the Trade (in US$) of Haiti in 2000 to that in 2001?
Provide a succinct answer. 1.02. What is the difference between the highest and the second highest Trade (in US$) of Middle East & North Africa (developing only)?
Provide a short and direct response. 8.51e+09. What is the difference between the highest and the second highest Trade (in US$) of El Salvador?
Provide a succinct answer. 1.78e+08. What is the difference between the highest and the second highest Trade (in US$) in Greece?
Provide a short and direct response. 2.69e+08. What is the difference between the highest and the second highest Trade (in US$) of Haiti?
Provide a short and direct response. 2.14e+07. What is the difference between the highest and the lowest Trade (in US$) of Middle East & North Africa (developing only)?
Make the answer very short. 4.13e+1. What is the difference between the highest and the lowest Trade (in US$) in El Salvador?
Offer a terse response. 2.90e+09. What is the difference between the highest and the lowest Trade (in US$) of Greece?
Your answer should be compact. 2.01e+1. What is the difference between the highest and the lowest Trade (in US$) in Haiti?
Make the answer very short. 7.85e+08. 